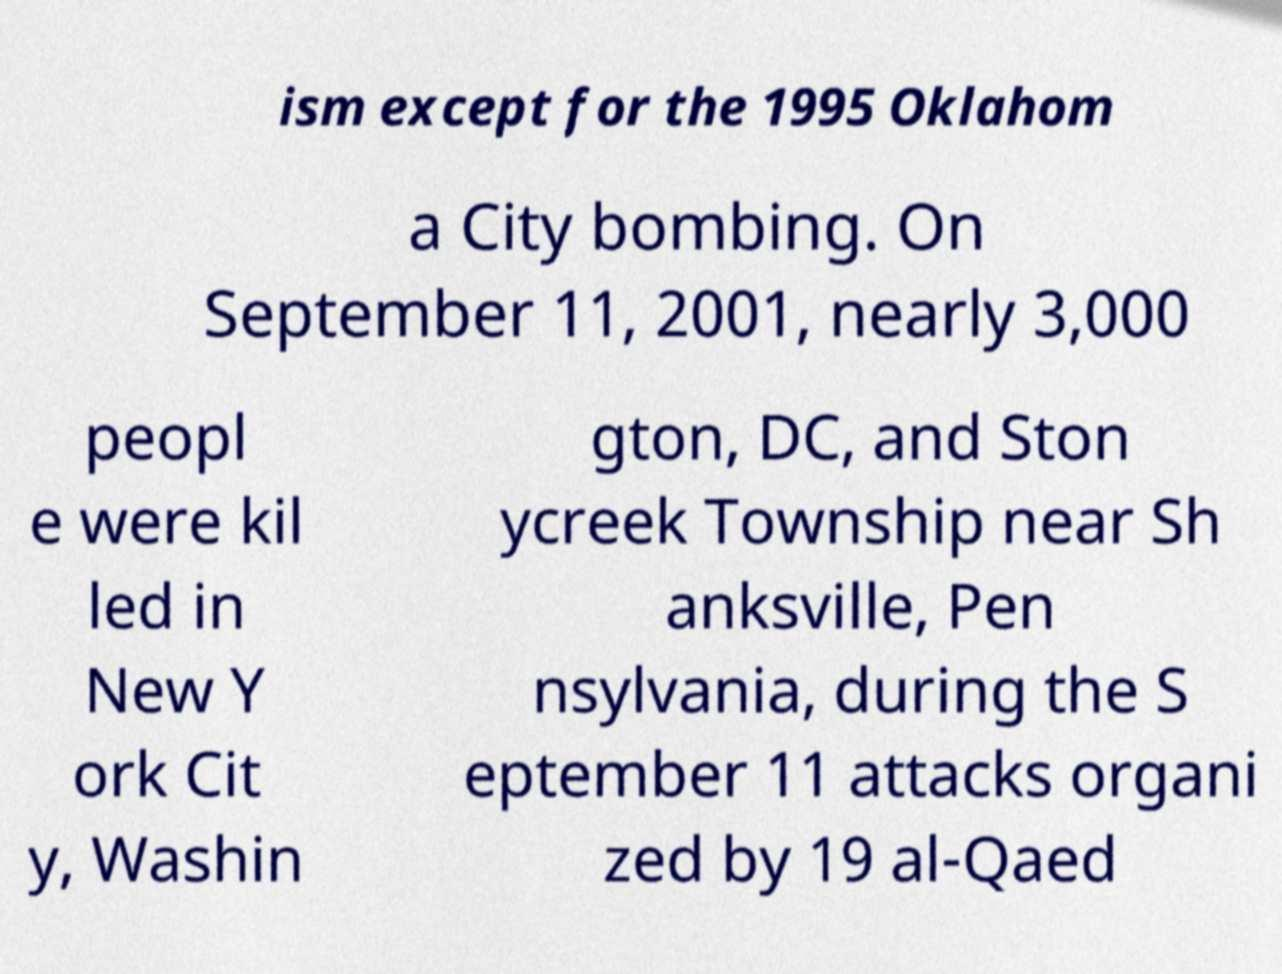Could you assist in decoding the text presented in this image and type it out clearly? ism except for the 1995 Oklahom a City bombing. On September 11, 2001, nearly 3,000 peopl e were kil led in New Y ork Cit y, Washin gton, DC, and Ston ycreek Township near Sh anksville, Pen nsylvania, during the S eptember 11 attacks organi zed by 19 al-Qaed 